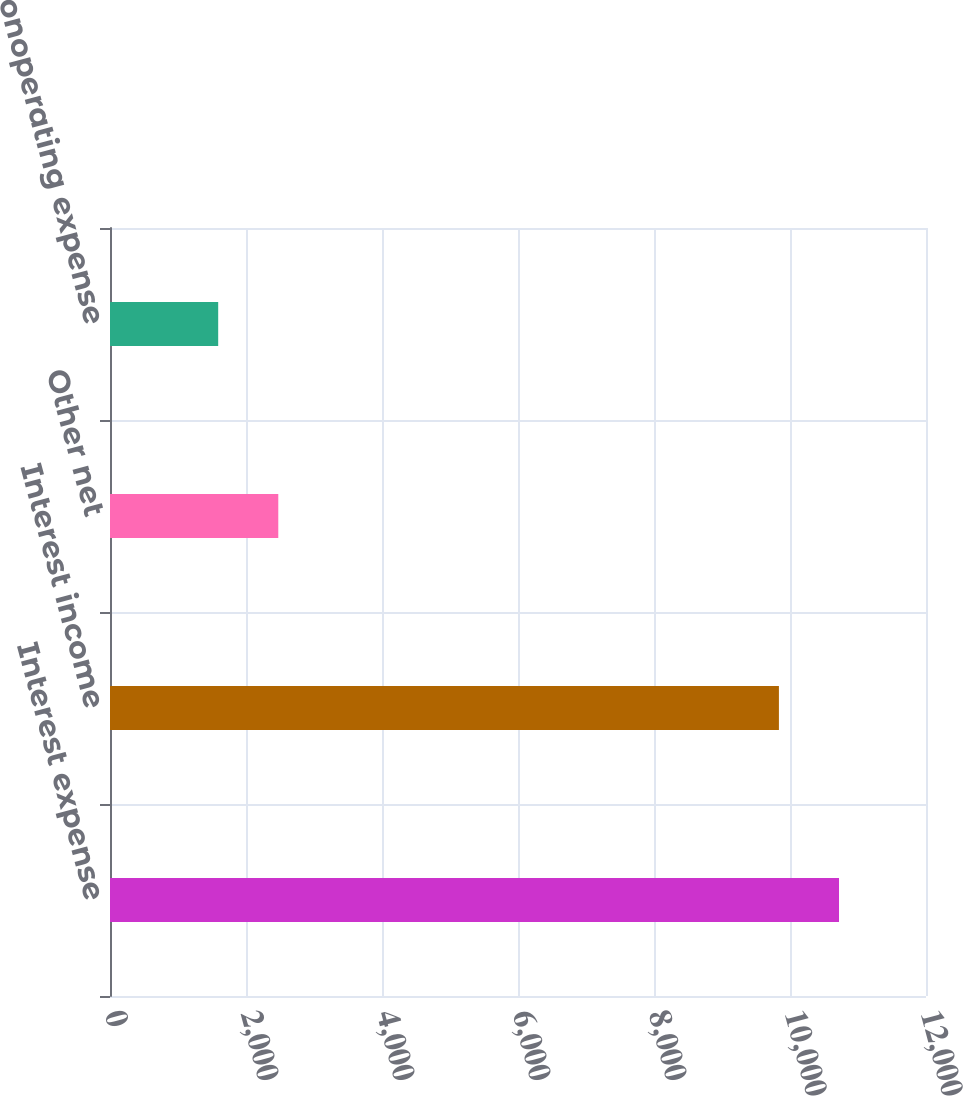Convert chart. <chart><loc_0><loc_0><loc_500><loc_500><bar_chart><fcel>Interest expense<fcel>Interest income<fcel>Other net<fcel>Total nonoperating expense<nl><fcel>10720.8<fcel>9837<fcel>2474.8<fcel>1591<nl></chart> 